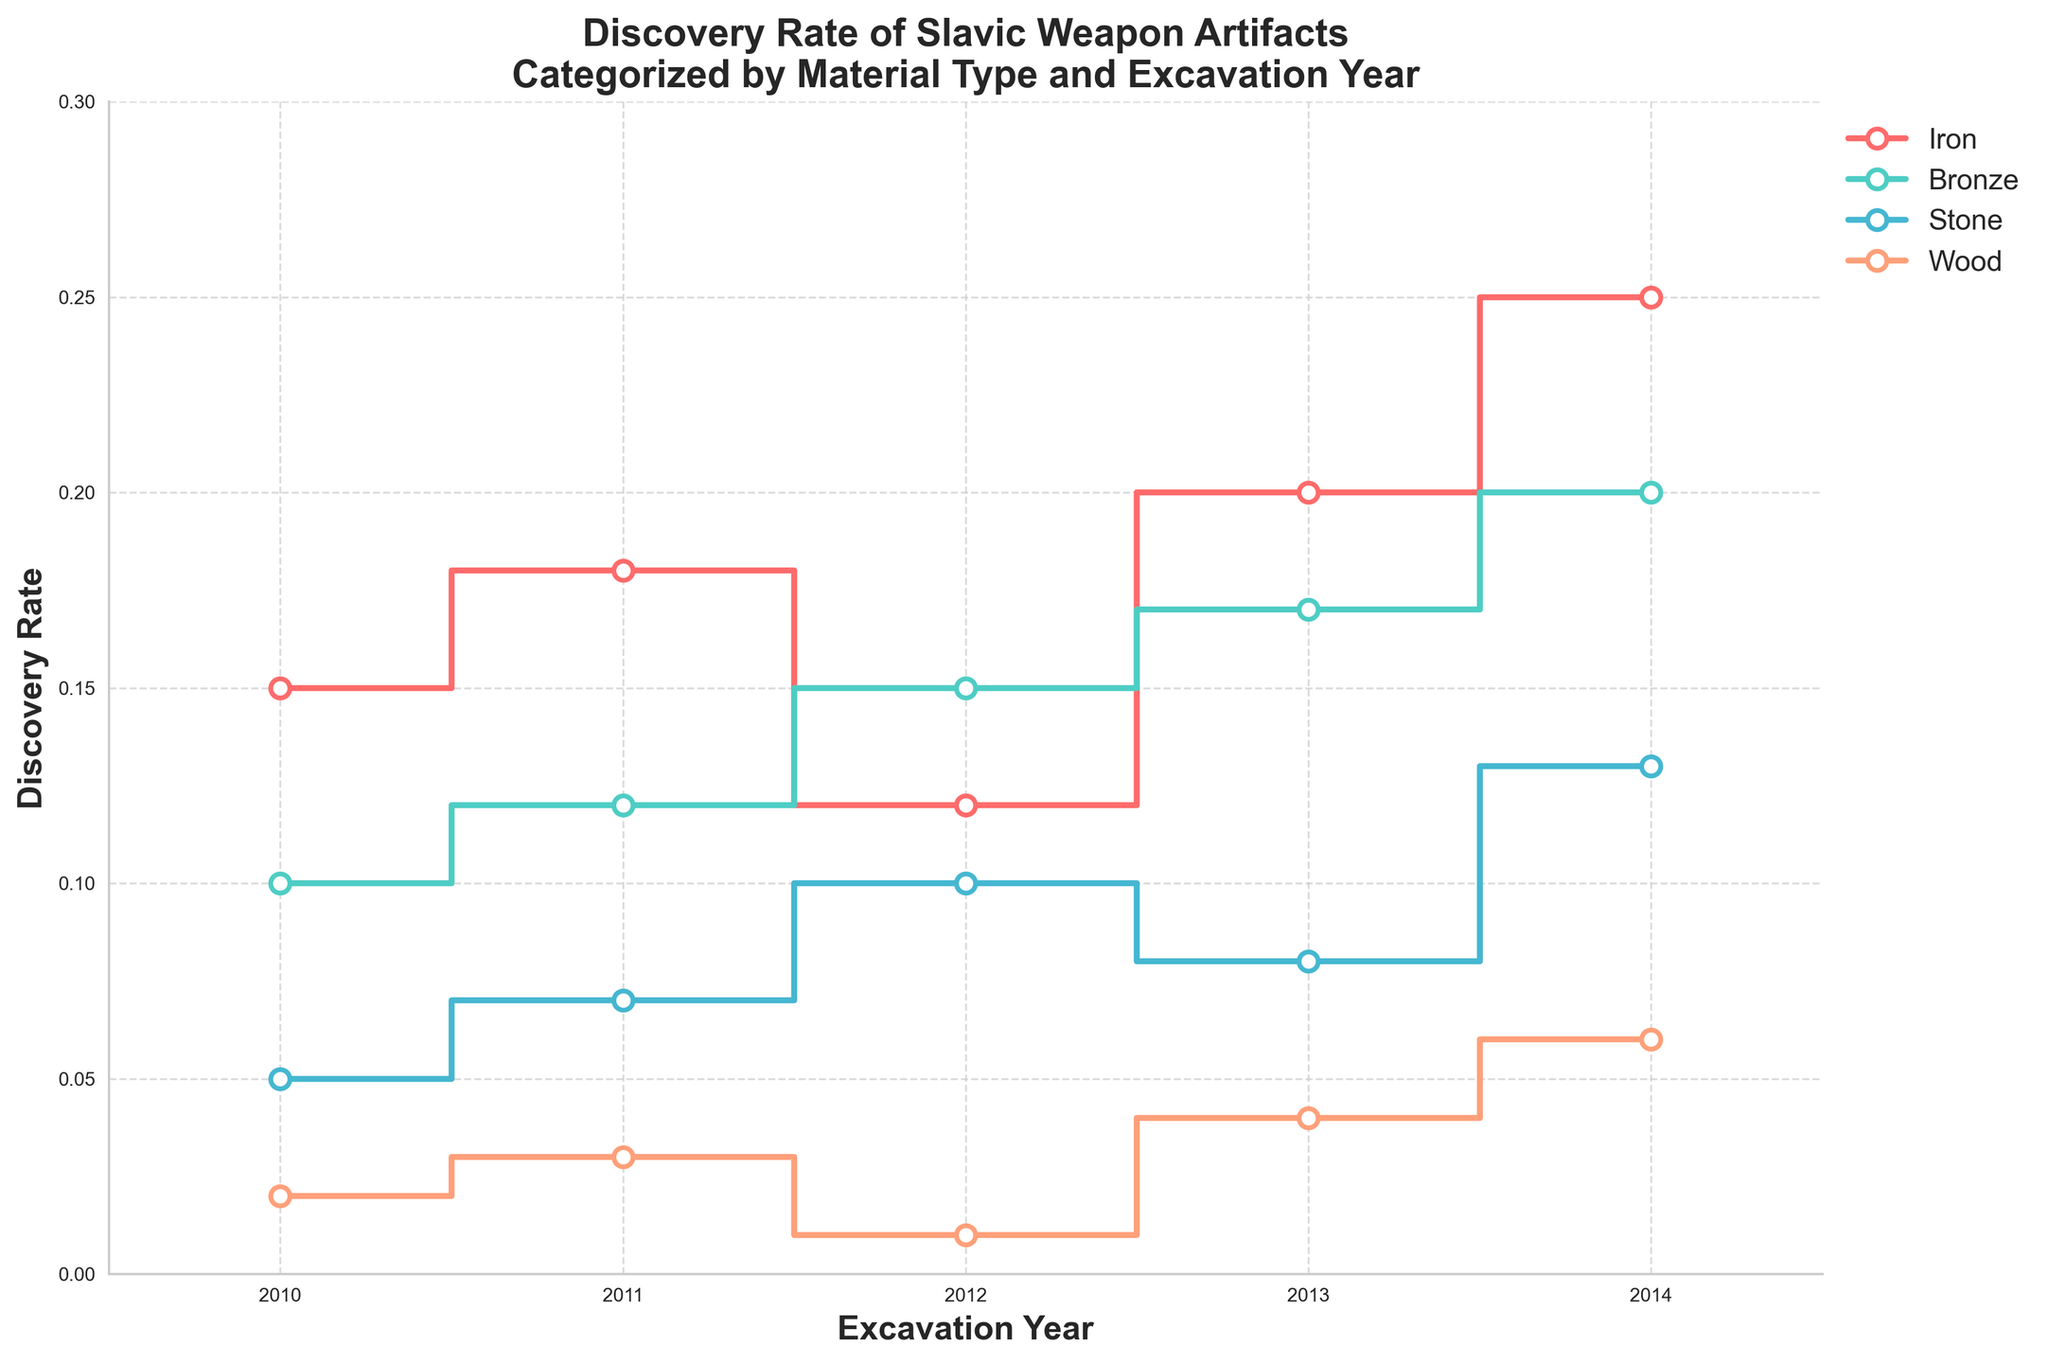What is the title of the plot? The title is displayed at the top of the plot, indicating the topic covered. It reads: "Discovery Rate of Slavic Weapon Artifacts Categorized by Material Type and Excavation Year".
Answer: Discovery Rate of Slavic Weapon Artifacts Categorized by Material Type and Excavation Year Which material type has the highest discovery rate in 2014? To find this, look at the point on the plot for the year 2014 for each material type and identify which one is the highest. The highest point is for Iron with a 0.25 discovery rate.
Answer: Iron How does the discovery rate of Bronze artifacts change from 2010 to 2014? Trace the line corresponding to Bronze from 2010 to 2014. The discovery rate increases from 0.10 in 2010 to 0.20 in 2014, showing a steady rise.
Answer: It steadily increases What is the difference in discovery rates between Iron and Wood in 2014? Identify the discovery rates for Iron and Wood in 2014. Iron is at 0.25 and Wood is at 0.06. Subtract the latter from the former: 0.25 - 0.06 = 0.19.
Answer: 0.19 Which year saw the highest overall discovery rate for Stone artifacts? Track the highest point along the Stone line from 2010 to 2014. The highest point is in 2014 with a 0.13 discovery rate.
Answer: 2014 Compare the trends of discovery rates for Iron and Stone artifacts from 2010 to 2014. Observing the steps for each year: Iron shows fluctuation with a general increase by 2014, while Stone shows a consistent rise except for a slight dip in 2013.
Answer: Iron fluctuates, Stone mostly rises with a dip in 2013 What is the combined average discovery rate for all material types in 2012? Sum the discovery rates for all materials in 2012 and divide by the number of materials. (0.12 + 0.15 + 0.10 + 0.01) / 4 = 0.095.
Answer: 0.095 Did the discovery rate for any material type remain the same for consecutive years? Examine each material's line for points where the rates are the same for two consecutive years. None of the materials show a flat line for two consecutive years.
Answer: No Which material type shows the most significant increase in discovery rate over the 5-year period? Compare the net increase from 2010 to 2014 for each material: Iron (0.10), Bronze (0.10), Stone (0.08), Wood (0.04). Both Iron and Bronze show the largest increase of 0.10.
Answer: Iron and Bronze What is the difference between the highest and lowest discovery rates recorded overall? The highest recorded is Iron at 0.25 in 2014 and the lowest is Wood at 0.01 in 2012. The difference is 0.25 - 0.01 = 0.24.
Answer: 0.24 